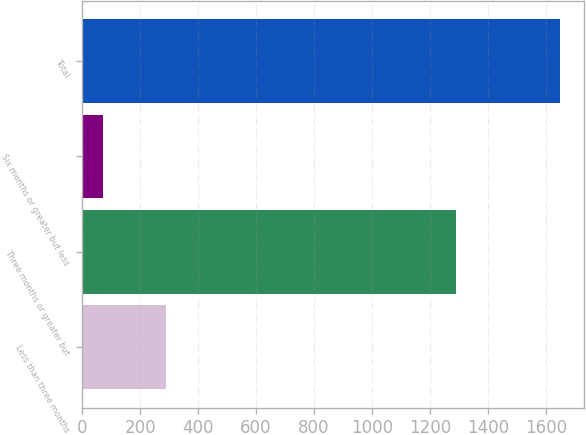Convert chart. <chart><loc_0><loc_0><loc_500><loc_500><bar_chart><fcel>Less than three months<fcel>Three months or greater but<fcel>Six months or greater but less<fcel>Total<nl><fcel>288<fcel>1289<fcel>72<fcel>1649<nl></chart> 